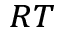<formula> <loc_0><loc_0><loc_500><loc_500>_ { R T }</formula> 